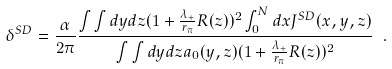Convert formula to latex. <formula><loc_0><loc_0><loc_500><loc_500>\delta ^ { S D } = \frac { \alpha } { 2 \pi } \frac { \int \int d y d z ( 1 + \frac { \lambda _ { + } } { r _ { \pi } } R ( z ) ) ^ { 2 } \int _ { 0 } ^ { N } d x J ^ { S D } ( x , y , z ) } { \int \int d y d z a _ { 0 } ( y , z ) ( 1 + \frac { \lambda _ { + } } { r _ { \pi } } R ( z ) ) ^ { 2 } } \ .</formula> 